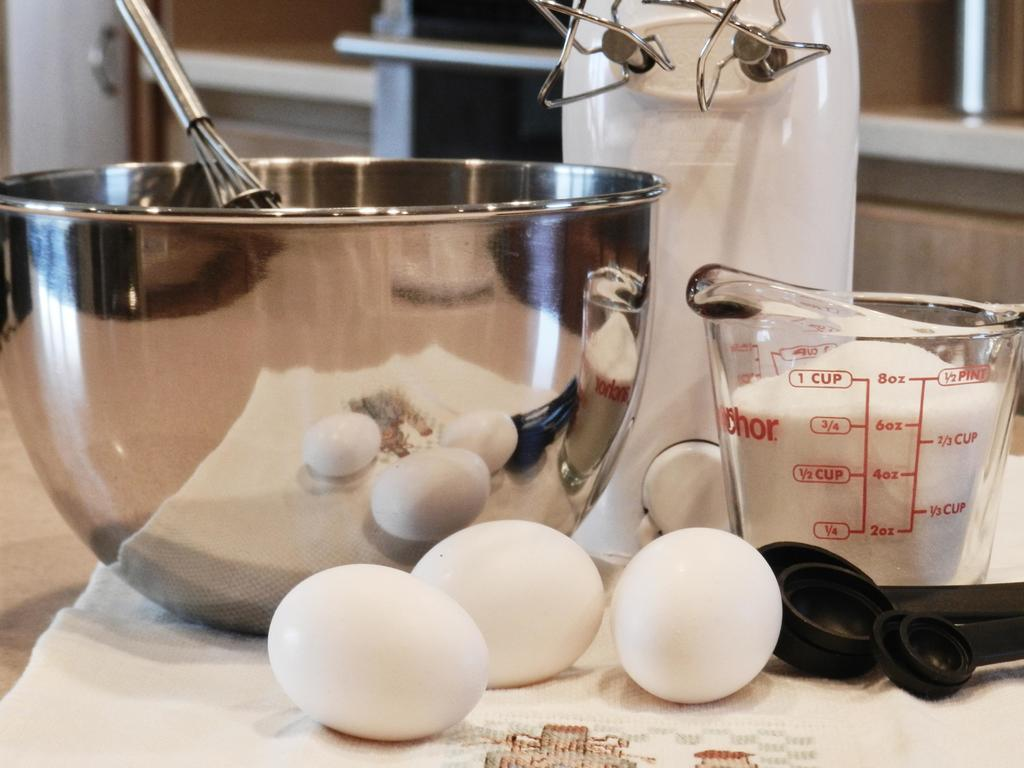<image>
Relay a brief, clear account of the picture shown. 3 eggs and 6 ounces of milk are shown on a counter near a bowl. 